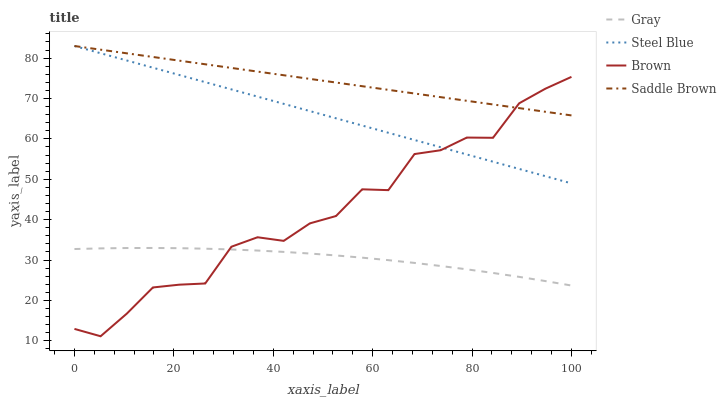Does Gray have the minimum area under the curve?
Answer yes or no. Yes. Does Saddle Brown have the maximum area under the curve?
Answer yes or no. Yes. Does Steel Blue have the minimum area under the curve?
Answer yes or no. No. Does Steel Blue have the maximum area under the curve?
Answer yes or no. No. Is Steel Blue the smoothest?
Answer yes or no. Yes. Is Brown the roughest?
Answer yes or no. Yes. Is Gray the smoothest?
Answer yes or no. No. Is Gray the roughest?
Answer yes or no. No. Does Brown have the lowest value?
Answer yes or no. Yes. Does Gray have the lowest value?
Answer yes or no. No. Does Steel Blue have the highest value?
Answer yes or no. Yes. Does Gray have the highest value?
Answer yes or no. No. Is Gray less than Steel Blue?
Answer yes or no. Yes. Is Saddle Brown greater than Gray?
Answer yes or no. Yes. Does Steel Blue intersect Brown?
Answer yes or no. Yes. Is Steel Blue less than Brown?
Answer yes or no. No. Is Steel Blue greater than Brown?
Answer yes or no. No. Does Gray intersect Steel Blue?
Answer yes or no. No. 